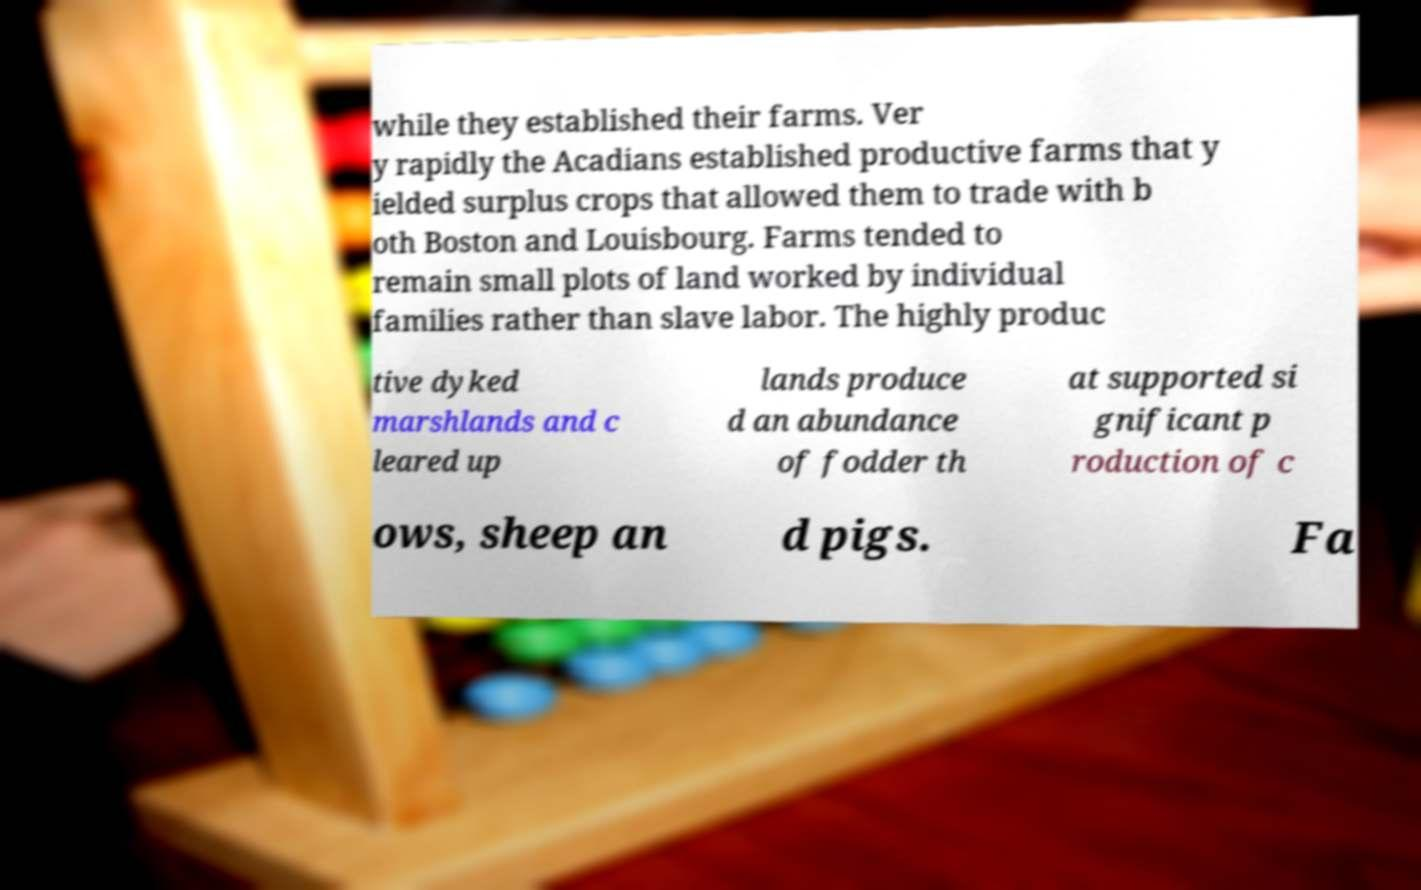What messages or text are displayed in this image? I need them in a readable, typed format. while they established their farms. Ver y rapidly the Acadians established productive farms that y ielded surplus crops that allowed them to trade with b oth Boston and Louisbourg. Farms tended to remain small plots of land worked by individual families rather than slave labor. The highly produc tive dyked marshlands and c leared up lands produce d an abundance of fodder th at supported si gnificant p roduction of c ows, sheep an d pigs. Fa 